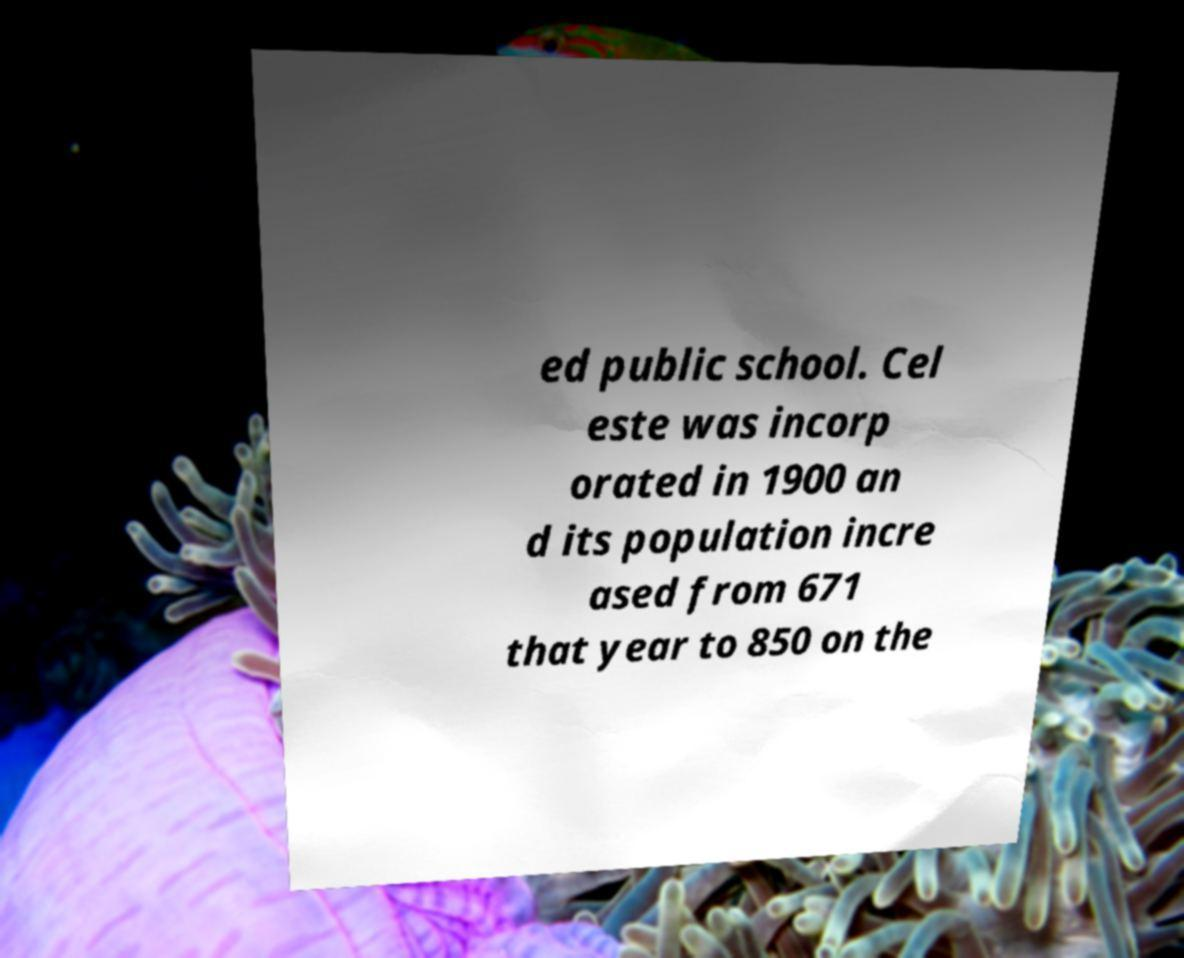Could you assist in decoding the text presented in this image and type it out clearly? ed public school. Cel este was incorp orated in 1900 an d its population incre ased from 671 that year to 850 on the 